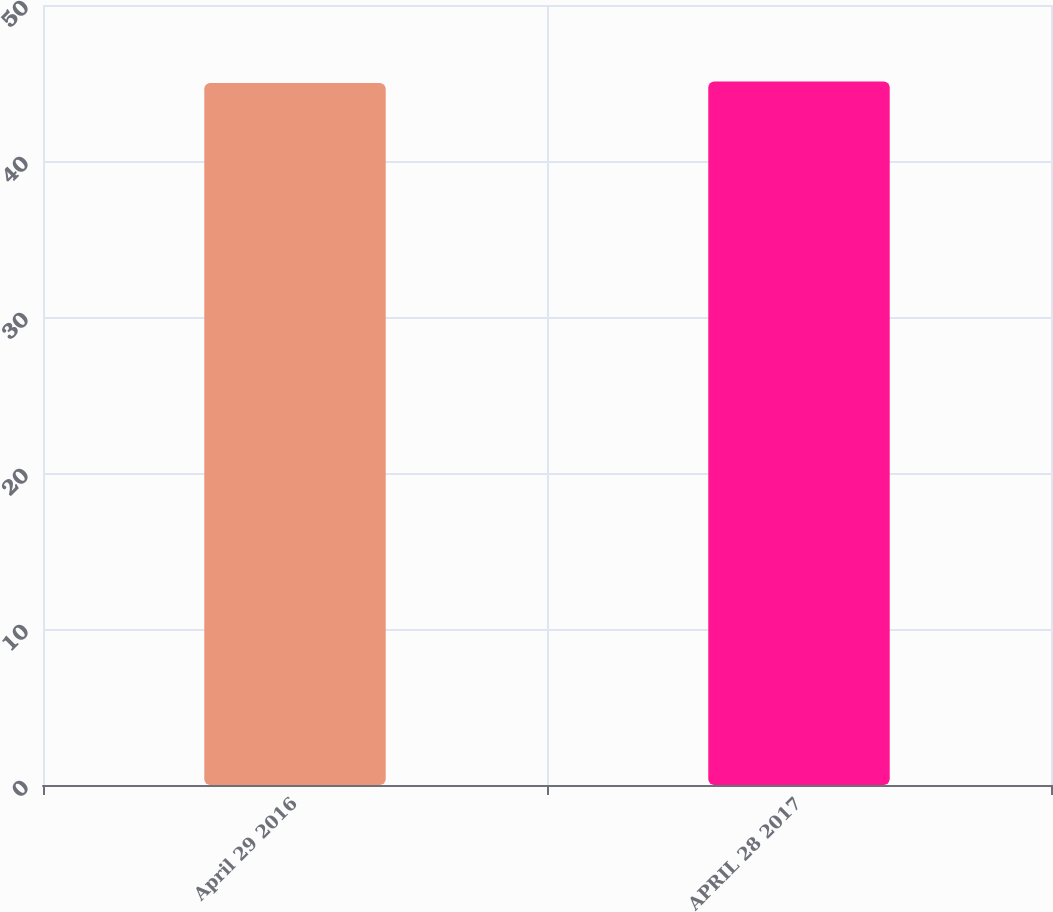<chart> <loc_0><loc_0><loc_500><loc_500><bar_chart><fcel>April 29 2016<fcel>APRIL 28 2017<nl><fcel>45<fcel>45.1<nl></chart> 